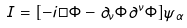Convert formula to latex. <formula><loc_0><loc_0><loc_500><loc_500>I = [ - i \Box \Phi - \partial _ { \nu } \Phi \partial ^ { \nu } \Phi ] \psi _ { \alpha }</formula> 